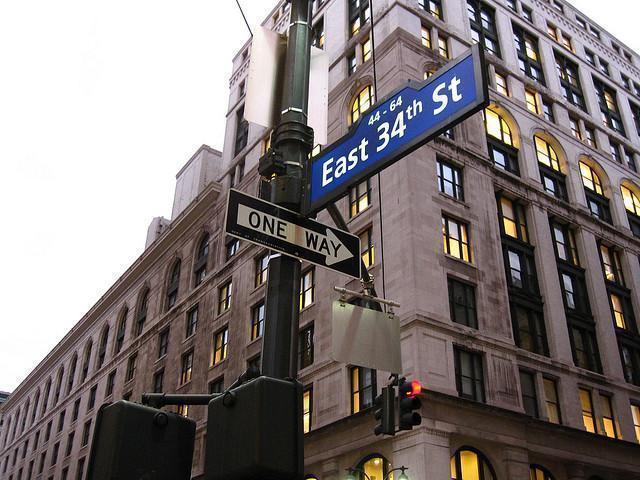What are is the image from?
From the following four choices, select the correct answer to address the question.
Options: City, forest, sky, underground. City. 